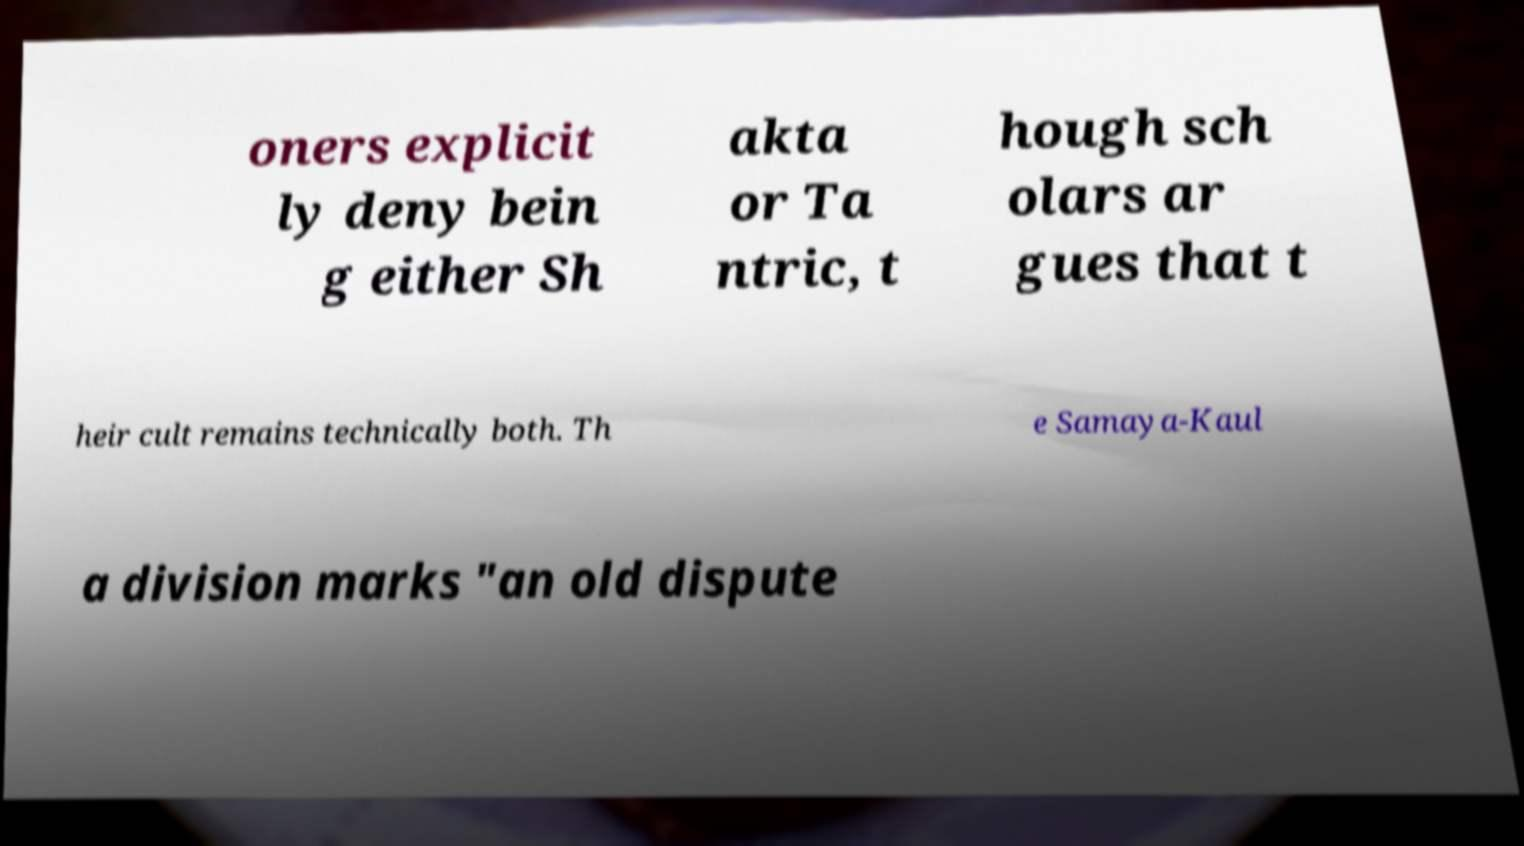Please read and relay the text visible in this image. What does it say? oners explicit ly deny bein g either Sh akta or Ta ntric, t hough sch olars ar gues that t heir cult remains technically both. Th e Samaya-Kaul a division marks "an old dispute 